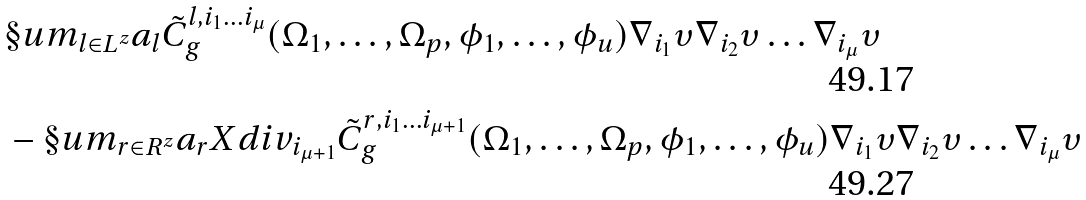Convert formula to latex. <formula><loc_0><loc_0><loc_500><loc_500>& \S u m _ { l \in L ^ { z } } a _ { l } \tilde { C } ^ { l , i _ { 1 } \dots i _ { \mu } } _ { g } ( \Omega _ { 1 } , \dots , \Omega _ { p } , \phi _ { 1 } , \dots , \phi _ { u } ) \nabla _ { i _ { 1 } } \upsilon \nabla _ { i _ { 2 } } \upsilon \dots \nabla _ { i _ { \mu } } \upsilon \\ & - \S u m _ { r \in R ^ { z } } a _ { r } X d i v _ { i _ { \mu + 1 } } \tilde { C } ^ { r , i _ { 1 } \dots i _ { \mu + 1 } } _ { g } ( \Omega _ { 1 } , \dots , \Omega _ { p } , \phi _ { 1 } , \dots , \phi _ { u } ) \nabla _ { i _ { 1 } } \upsilon \nabla _ { i _ { 2 } } \upsilon \dots \nabla _ { i _ { \mu } } \upsilon</formula> 